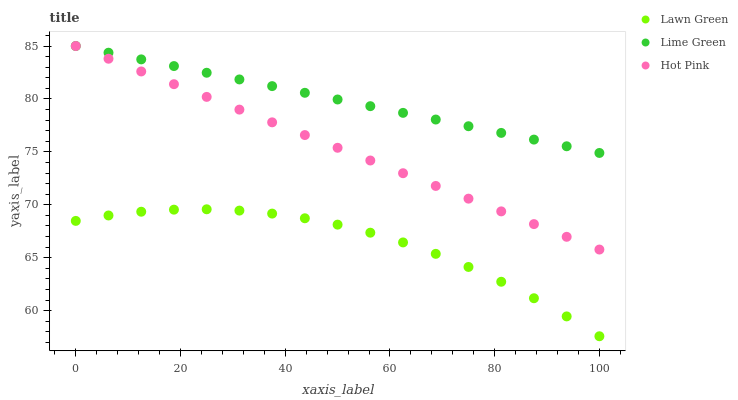Does Lawn Green have the minimum area under the curve?
Answer yes or no. Yes. Does Lime Green have the maximum area under the curve?
Answer yes or no. Yes. Does Hot Pink have the minimum area under the curve?
Answer yes or no. No. Does Hot Pink have the maximum area under the curve?
Answer yes or no. No. Is Hot Pink the smoothest?
Answer yes or no. Yes. Is Lawn Green the roughest?
Answer yes or no. Yes. Is Lime Green the smoothest?
Answer yes or no. No. Is Lime Green the roughest?
Answer yes or no. No. Does Lawn Green have the lowest value?
Answer yes or no. Yes. Does Hot Pink have the lowest value?
Answer yes or no. No. Does Lime Green have the highest value?
Answer yes or no. Yes. Is Lawn Green less than Hot Pink?
Answer yes or no. Yes. Is Lime Green greater than Lawn Green?
Answer yes or no. Yes. Does Lime Green intersect Hot Pink?
Answer yes or no. Yes. Is Lime Green less than Hot Pink?
Answer yes or no. No. Is Lime Green greater than Hot Pink?
Answer yes or no. No. Does Lawn Green intersect Hot Pink?
Answer yes or no. No. 